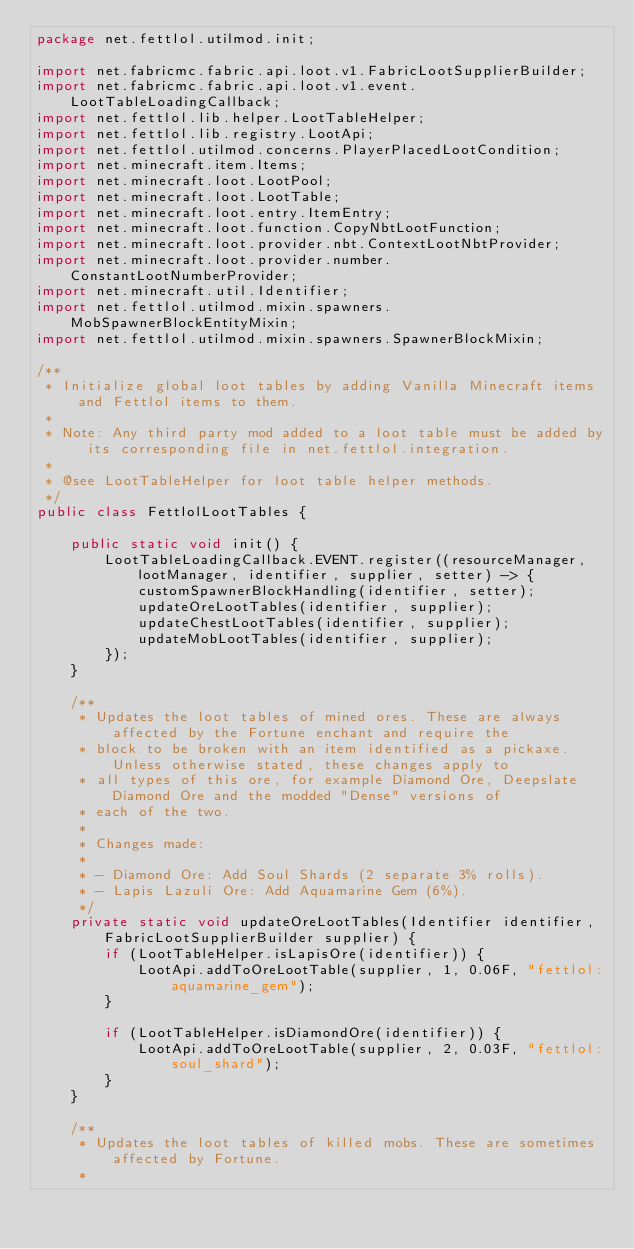Convert code to text. <code><loc_0><loc_0><loc_500><loc_500><_Java_>package net.fettlol.utilmod.init;

import net.fabricmc.fabric.api.loot.v1.FabricLootSupplierBuilder;
import net.fabricmc.fabric.api.loot.v1.event.LootTableLoadingCallback;
import net.fettlol.lib.helper.LootTableHelper;
import net.fettlol.lib.registry.LootApi;
import net.fettlol.utilmod.concerns.PlayerPlacedLootCondition;
import net.minecraft.item.Items;
import net.minecraft.loot.LootPool;
import net.minecraft.loot.LootTable;
import net.minecraft.loot.entry.ItemEntry;
import net.minecraft.loot.function.CopyNbtLootFunction;
import net.minecraft.loot.provider.nbt.ContextLootNbtProvider;
import net.minecraft.loot.provider.number.ConstantLootNumberProvider;
import net.minecraft.util.Identifier;
import net.fettlol.utilmod.mixin.spawners.MobSpawnerBlockEntityMixin;
import net.fettlol.utilmod.mixin.spawners.SpawnerBlockMixin;

/**
 * Initialize global loot tables by adding Vanilla Minecraft items and Fettlol items to them.
 *
 * Note: Any third party mod added to a loot table must be added by its corresponding file in net.fettlol.integration.
 *
 * @see LootTableHelper for loot table helper methods.
 */
public class FettlolLootTables {

    public static void init() {
        LootTableLoadingCallback.EVENT.register((resourceManager, lootManager, identifier, supplier, setter) -> {
            customSpawnerBlockHandling(identifier, setter);
            updateOreLootTables(identifier, supplier);
            updateChestLootTables(identifier, supplier);
            updateMobLootTables(identifier, supplier);
        });
    }

    /**
     * Updates the loot tables of mined ores. These are always affected by the Fortune enchant and require the
     * block to be broken with an item identified as a pickaxe. Unless otherwise stated, these changes apply to
     * all types of this ore, for example Diamond Ore, Deepslate Diamond Ore and the modded "Dense" versions of
     * each of the two.
     *
     * Changes made:
     *
     * - Diamond Ore: Add Soul Shards (2 separate 3% rolls).
     * - Lapis Lazuli Ore: Add Aquamarine Gem (6%).
     */
    private static void updateOreLootTables(Identifier identifier, FabricLootSupplierBuilder supplier) {
        if (LootTableHelper.isLapisOre(identifier)) {
            LootApi.addToOreLootTable(supplier, 1, 0.06F, "fettlol:aquamarine_gem");
        }

        if (LootTableHelper.isDiamondOre(identifier)) {
            LootApi.addToOreLootTable(supplier, 2, 0.03F, "fettlol:soul_shard");
        }
    }

    /**
     * Updates the loot tables of killed mobs. These are sometimes affected by Fortune.
     *</code> 